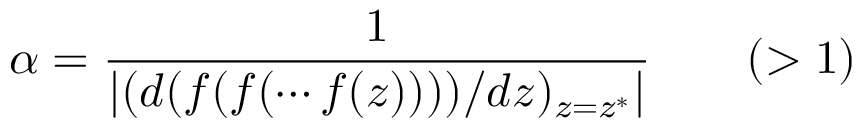Convert formula to latex. <formula><loc_0><loc_0><loc_500><loc_500>\alpha = { \frac { 1 } { \left | ( d ( f ( f ( \cdots f ( z ) ) ) ) / d z ) _ { z = z ^ { * } } \right | } } \quad ( > 1 )</formula> 